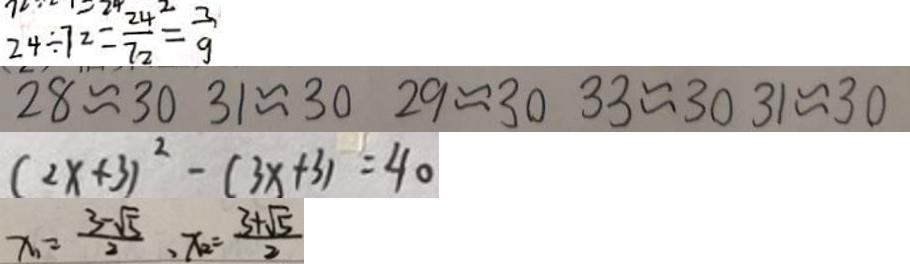<formula> <loc_0><loc_0><loc_500><loc_500>2 4 \div 7 2 = \frac { 2 4 } { 7 2 } = \frac { 3 } { 9 } 
 2 8 \approx 3 0 3 1 \approx 3 0 2 9 \approx 3 0 3 3 \approx 3 0 3 1 \approx 3 0 
 ( 2 x + 3 ) ^ { 2 } - ( 3 x + 3 ) = 4 0 
 x _ { 1 } = \frac { 3 - \sqrt { 5 } } { 2 } , x _ { 2 } = \frac { 3 + \sqrt { 5 } } { 2 }</formula> 